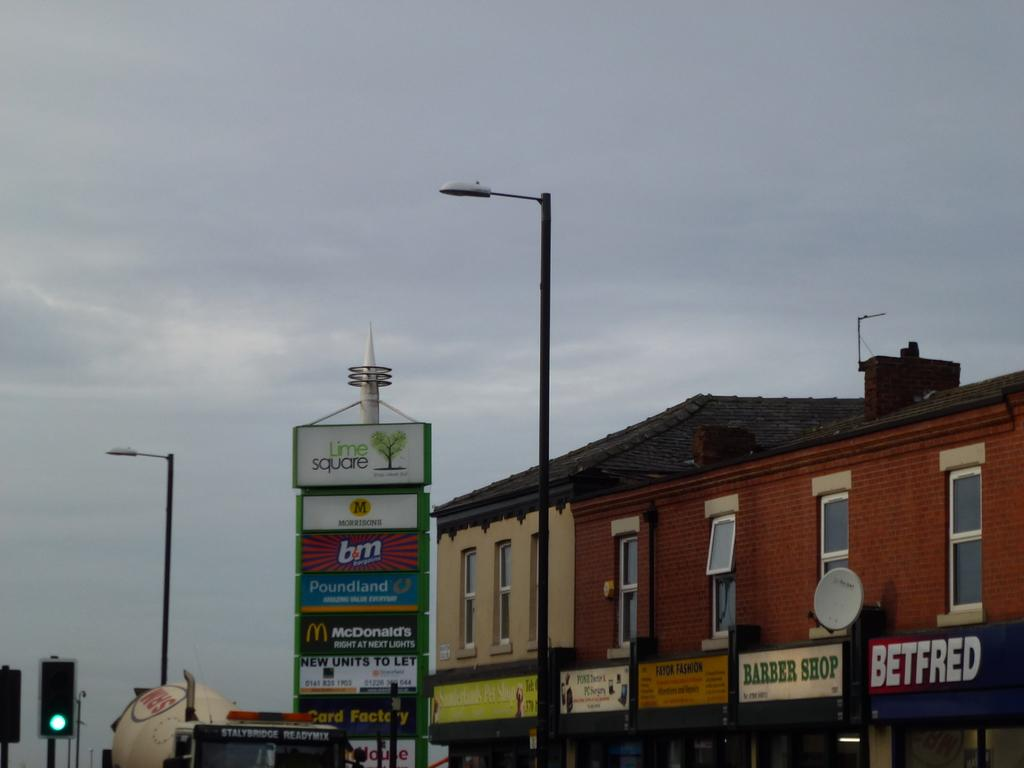<image>
Provide a brief description of the given image. Store fronts from the shopping plaza Lime Square 